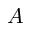Convert formula to latex. <formula><loc_0><loc_0><loc_500><loc_500>A</formula> 